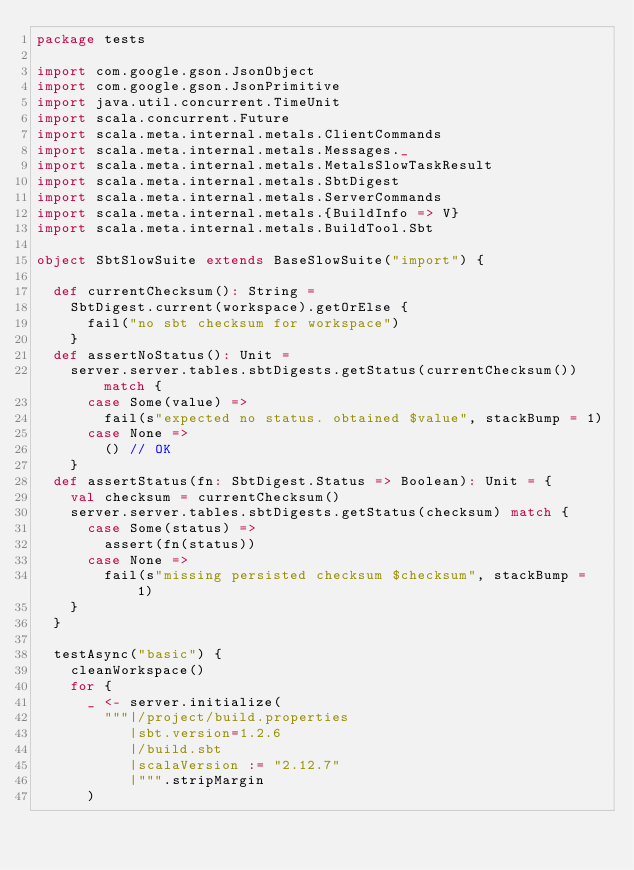Convert code to text. <code><loc_0><loc_0><loc_500><loc_500><_Scala_>package tests

import com.google.gson.JsonObject
import com.google.gson.JsonPrimitive
import java.util.concurrent.TimeUnit
import scala.concurrent.Future
import scala.meta.internal.metals.ClientCommands
import scala.meta.internal.metals.Messages._
import scala.meta.internal.metals.MetalsSlowTaskResult
import scala.meta.internal.metals.SbtDigest
import scala.meta.internal.metals.ServerCommands
import scala.meta.internal.metals.{BuildInfo => V}
import scala.meta.internal.metals.BuildTool.Sbt

object SbtSlowSuite extends BaseSlowSuite("import") {

  def currentChecksum(): String =
    SbtDigest.current(workspace).getOrElse {
      fail("no sbt checksum for workspace")
    }
  def assertNoStatus(): Unit =
    server.server.tables.sbtDigests.getStatus(currentChecksum()) match {
      case Some(value) =>
        fail(s"expected no status. obtained $value", stackBump = 1)
      case None =>
        () // OK
    }
  def assertStatus(fn: SbtDigest.Status => Boolean): Unit = {
    val checksum = currentChecksum()
    server.server.tables.sbtDigests.getStatus(checksum) match {
      case Some(status) =>
        assert(fn(status))
      case None =>
        fail(s"missing persisted checksum $checksum", stackBump = 1)
    }
  }

  testAsync("basic") {
    cleanWorkspace()
    for {
      _ <- server.initialize(
        """|/project/build.properties
           |sbt.version=1.2.6
           |/build.sbt
           |scalaVersion := "2.12.7"
           |""".stripMargin
      )</code> 